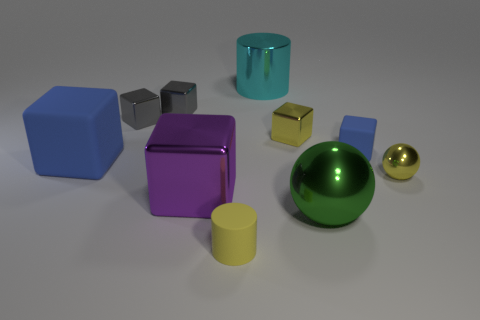Is there a tiny cube that has the same material as the large blue block? Yes, there is indeed a small cube in this image that shares the glossy, metallic appearance consistent with the material of the large blue block. 